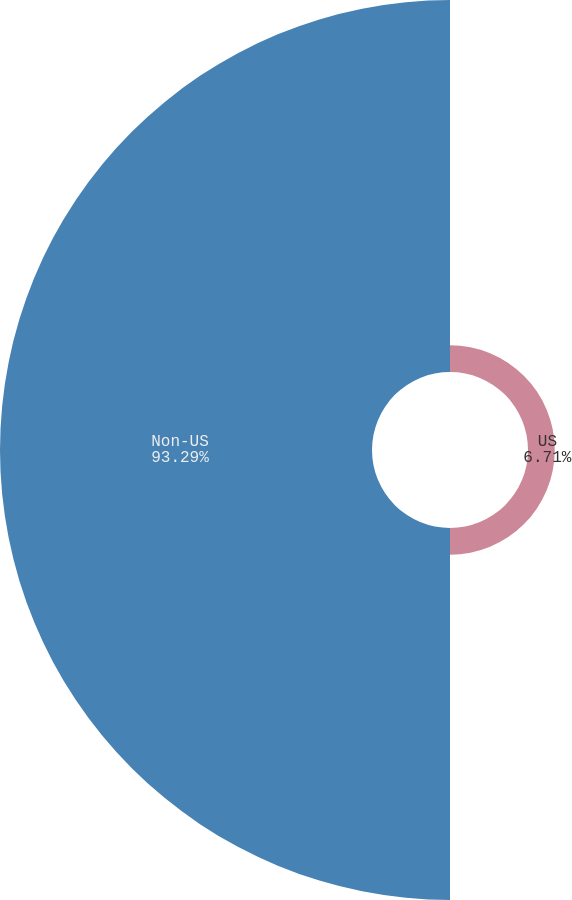Convert chart. <chart><loc_0><loc_0><loc_500><loc_500><pie_chart><fcel>US<fcel>Non-US<nl><fcel>6.71%<fcel>93.29%<nl></chart> 